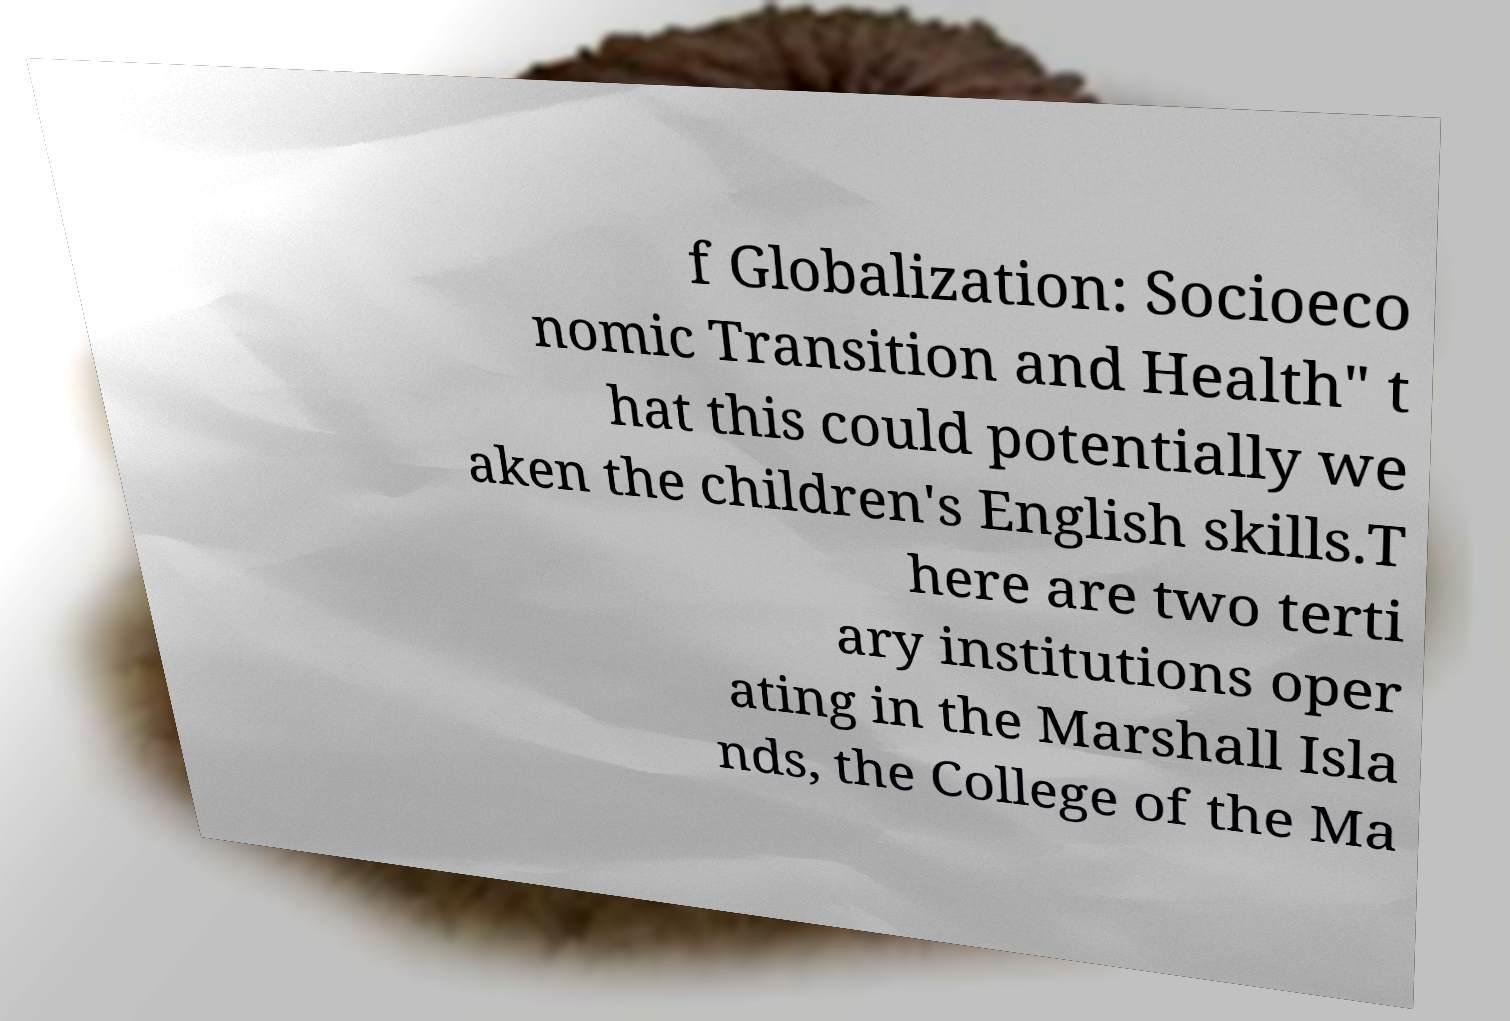There's text embedded in this image that I need extracted. Can you transcribe it verbatim? f Globalization: Socioeco nomic Transition and Health" t hat this could potentially we aken the children's English skills.T here are two terti ary institutions oper ating in the Marshall Isla nds, the College of the Ma 